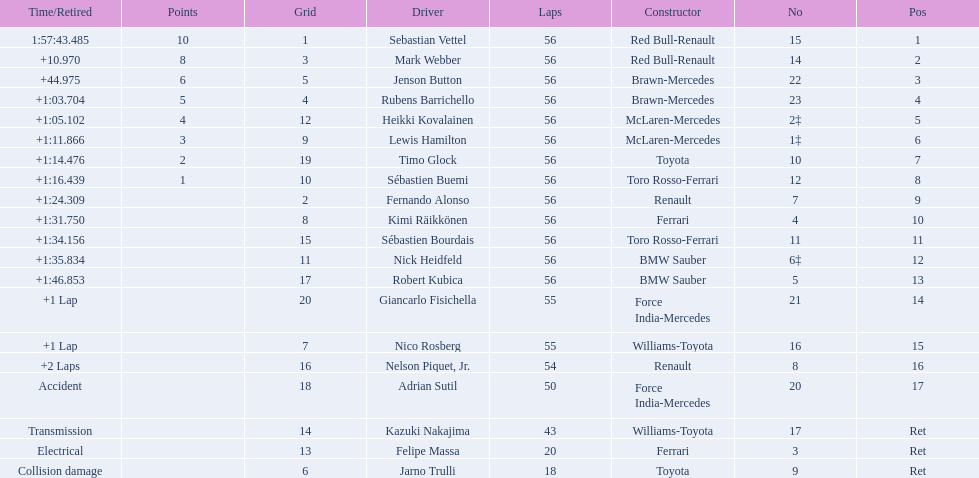Which drive retired because of electrical issues? Felipe Massa. Which driver retired due to accident? Adrian Sutil. Can you give me this table as a dict? {'header': ['Time/Retired', 'Points', 'Grid', 'Driver', 'Laps', 'Constructor', 'No', 'Pos'], 'rows': [['1:57:43.485', '10', '1', 'Sebastian Vettel', '56', 'Red Bull-Renault', '15', '1'], ['+10.970', '8', '3', 'Mark Webber', '56', 'Red Bull-Renault', '14', '2'], ['+44.975', '6', '5', 'Jenson Button', '56', 'Brawn-Mercedes', '22', '3'], ['+1:03.704', '5', '4', 'Rubens Barrichello', '56', 'Brawn-Mercedes', '23', '4'], ['+1:05.102', '4', '12', 'Heikki Kovalainen', '56', 'McLaren-Mercedes', '2‡', '5'], ['+1:11.866', '3', '9', 'Lewis Hamilton', '56', 'McLaren-Mercedes', '1‡', '6'], ['+1:14.476', '2', '19', 'Timo Glock', '56', 'Toyota', '10', '7'], ['+1:16.439', '1', '10', 'Sébastien Buemi', '56', 'Toro Rosso-Ferrari', '12', '8'], ['+1:24.309', '', '2', 'Fernando Alonso', '56', 'Renault', '7', '9'], ['+1:31.750', '', '8', 'Kimi Räikkönen', '56', 'Ferrari', '4', '10'], ['+1:34.156', '', '15', 'Sébastien Bourdais', '56', 'Toro Rosso-Ferrari', '11', '11'], ['+1:35.834', '', '11', 'Nick Heidfeld', '56', 'BMW Sauber', '6‡', '12'], ['+1:46.853', '', '17', 'Robert Kubica', '56', 'BMW Sauber', '5', '13'], ['+1 Lap', '', '20', 'Giancarlo Fisichella', '55', 'Force India-Mercedes', '21', '14'], ['+1 Lap', '', '7', 'Nico Rosberg', '55', 'Williams-Toyota', '16', '15'], ['+2 Laps', '', '16', 'Nelson Piquet, Jr.', '54', 'Renault', '8', '16'], ['Accident', '', '18', 'Adrian Sutil', '50', 'Force India-Mercedes', '20', '17'], ['Transmission', '', '14', 'Kazuki Nakajima', '43', 'Williams-Toyota', '17', 'Ret'], ['Electrical', '', '13', 'Felipe Massa', '20', 'Ferrari', '3', 'Ret'], ['Collision damage', '', '6', 'Jarno Trulli', '18', 'Toyota', '9', 'Ret']]} Which driver retired due to collision damage? Jarno Trulli. 